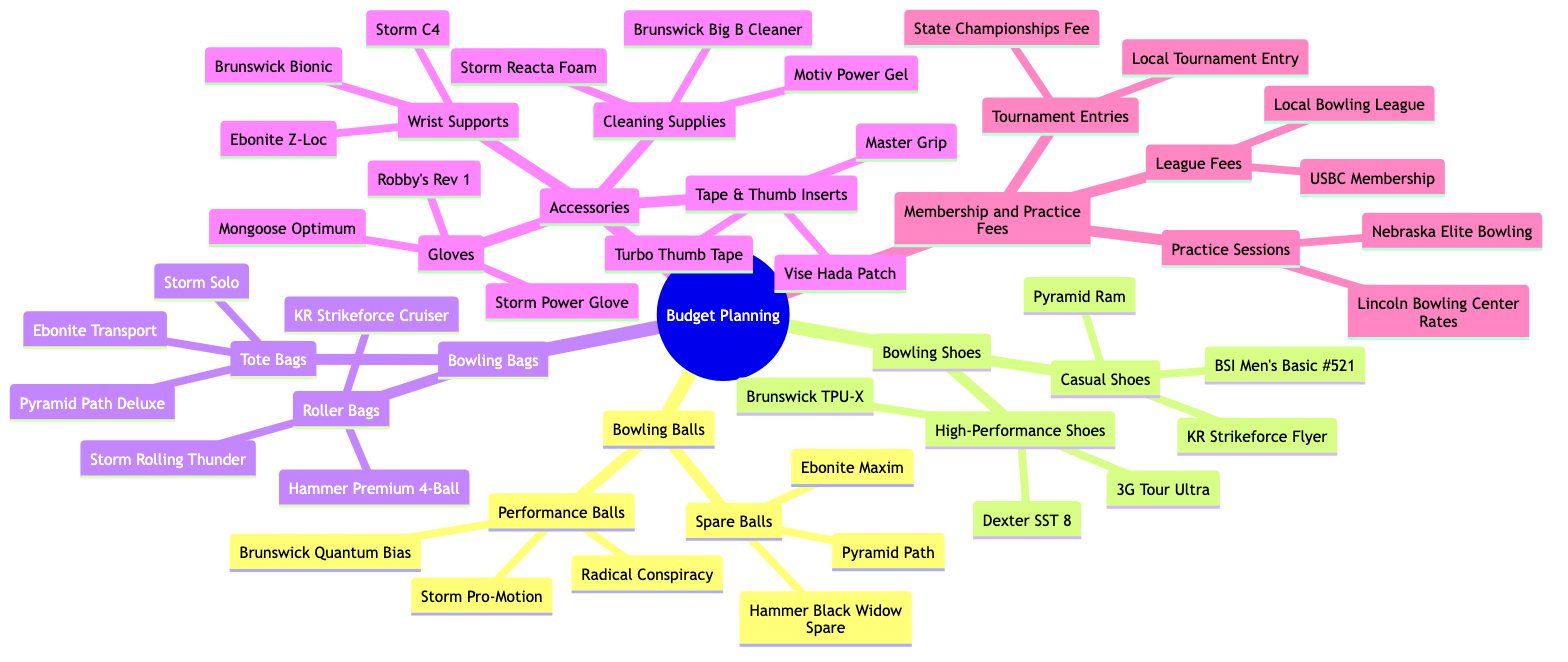What are the two categories of Bowling Balls? The diagram shows "Performance Balls" and "Spare Balls" as the two categories under the "Bowling Balls" node.
Answer: Performance Balls, Spare Balls How many types of Bowling Shoes are listed? The diagram outlines "High-Performance Shoes" and "Casual Shoes" as the two types, making a total of two types of Bowling Shoes.
Answer: 2 Name one brand of Cleaning Supplies listed in Accessories. Within the "Cleaning Supplies" section of Accessories, "Storm Reacta Foam" is one of the brands listed.
Answer: Storm Reacta Foam What category does the 'Brunswick Quantum Bias' fall under? The "Brunswick Quantum Bias" is located under the "Performance Balls" category within the "Bowling Balls" section of the diagram.
Answer: Performance Balls How many Roller Bags are mentioned in the diagram? The diagram lists three Roller Bags: "Hammer Premium 4-Ball," "Storm Rolling Thunder," and "KR Strikeforce Cruiser," totaling three Roller Bags.
Answer: 3 Which accessory has the most items listed? In the Accessories section, "Gloves," which lists three items, ties with "Wrist Supports," which also lists three items, making them the categories with the most items.
Answer: Gloves, Wrist Supports What is the relationship between League Fees and Membership and Practice Fees? "League Fees" is a subset of the "Membership and Practice Fees," indicating it is one of the categories included under this broader category in the diagram.
Answer: Subset Identify one type of Bowling Bag mentioned. The diagram mentions "Tote Bags" as one type of Bowling Bag under the "Bowling Bags" category.
Answer: Tote Bags What is the total number of different performance balls listed? "Performance Balls" lists three specific balls: "Storm Pro-Motion," "Brunswick Quantum Bias," and "Radical Conspiracy," giving a total of three performance balls.
Answer: 3 